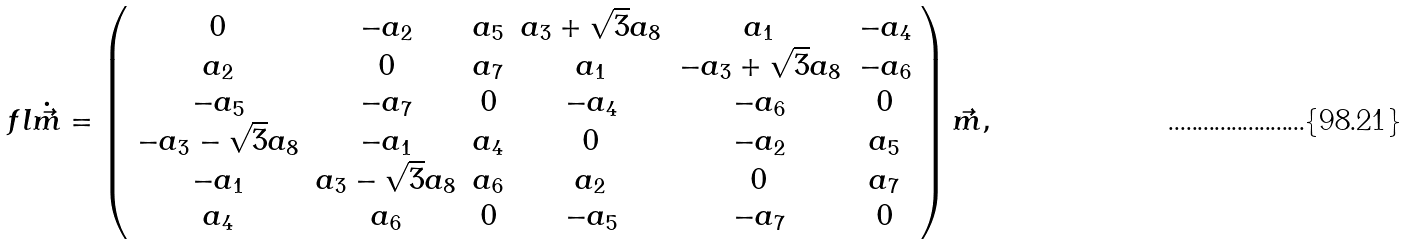Convert formula to latex. <formula><loc_0><loc_0><loc_500><loc_500>\ f l \dot { \vec { m } } = \left ( \begin{array} { c c c c c c } 0 & - a _ { 2 } & a _ { 5 } & a _ { 3 } + \sqrt { 3 } a _ { 8 } & a _ { 1 } & - a _ { 4 } \\ a _ { 2 } & 0 & a _ { 7 } & a _ { 1 } & - a _ { 3 } + \sqrt { 3 } a _ { 8 } & - a _ { 6 } \\ - a _ { 5 } & - a _ { 7 } & 0 & - a _ { 4 } & - a _ { 6 } & 0 \\ - a _ { 3 } - \sqrt { 3 } a _ { 8 } & - a _ { 1 } & a _ { 4 } & 0 & - a _ { 2 } & a _ { 5 } \\ - a _ { 1 } & a _ { 3 } - \sqrt { 3 } a _ { 8 } & a _ { 6 } & a _ { 2 } & 0 & a _ { 7 } \\ a _ { 4 } & a _ { 6 } & 0 & - a _ { 5 } & - a _ { 7 } & 0 \\ \end{array} \right ) \vec { m } ,</formula> 